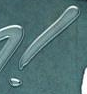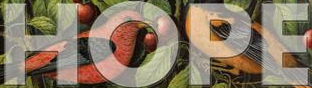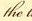What text appears in these images from left to right, separated by a semicolon? !; HOPE; the 